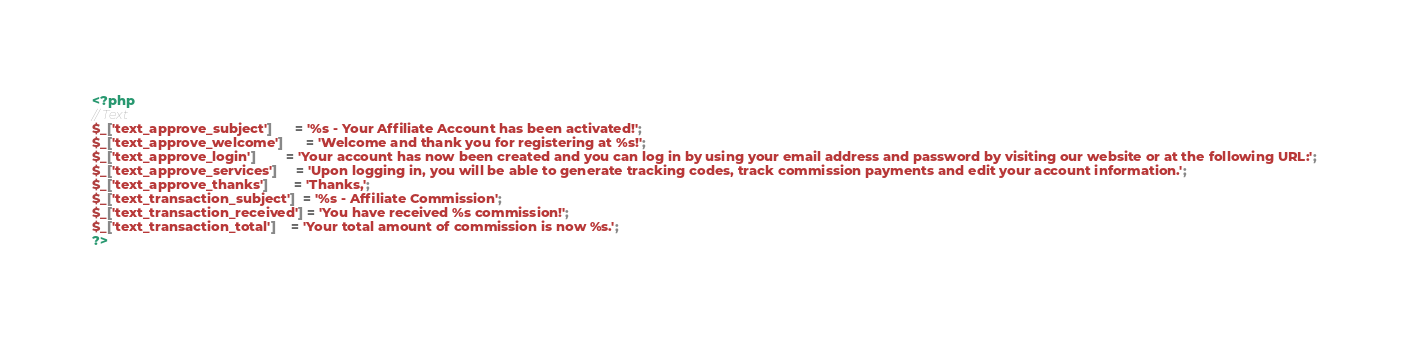<code> <loc_0><loc_0><loc_500><loc_500><_PHP_><?php
// Text
$_['text_approve_subject']      = '%s - Your Affiliate Account has been activated!';
$_['text_approve_welcome']      = 'Welcome and thank you for registering at %s!';
$_['text_approve_login']        = 'Your account has now been created and you can log in by using your email address and password by visiting our website or at the following URL:';
$_['text_approve_services']     = 'Upon logging in, you will be able to generate tracking codes, track commission payments and edit your account information.';
$_['text_approve_thanks']       = 'Thanks,';
$_['text_transaction_subject']  = '%s - Affiliate Commission';
$_['text_transaction_received'] = 'You have received %s commission!';
$_['text_transaction_total']    = 'Your total amount of commission is now %s.';
?></code> 